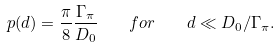Convert formula to latex. <formula><loc_0><loc_0><loc_500><loc_500>p ( d ) = \frac { \pi } { 8 } \frac { \Gamma _ { \pi } } { D _ { 0 } } \quad f o r \quad d \ll D _ { 0 } / \Gamma _ { \pi } .</formula> 